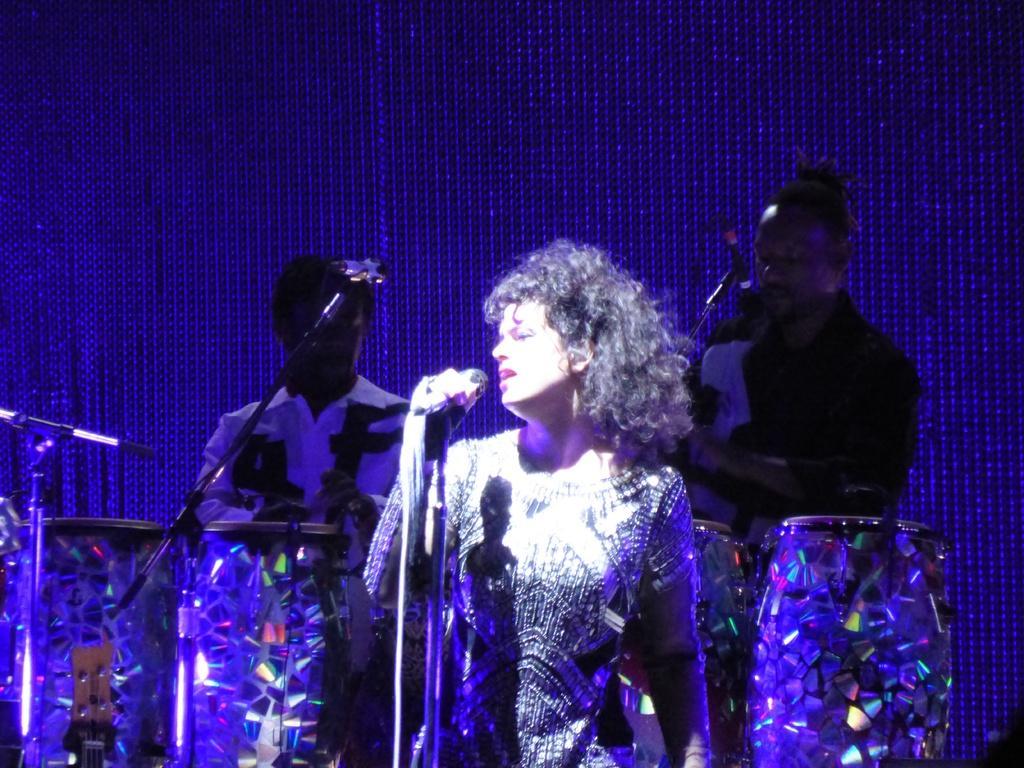Could you give a brief overview of what you see in this image? In the image I can see a person who is standing in front of the mic and behind there are two other people playing drums. 